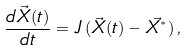<formula> <loc_0><loc_0><loc_500><loc_500>\frac { d \vec { X } ( t ) } { d t } = J \left ( \vec { X } ( t ) - \vec { X ^ { ^ { * } } } \right ) ,</formula> 